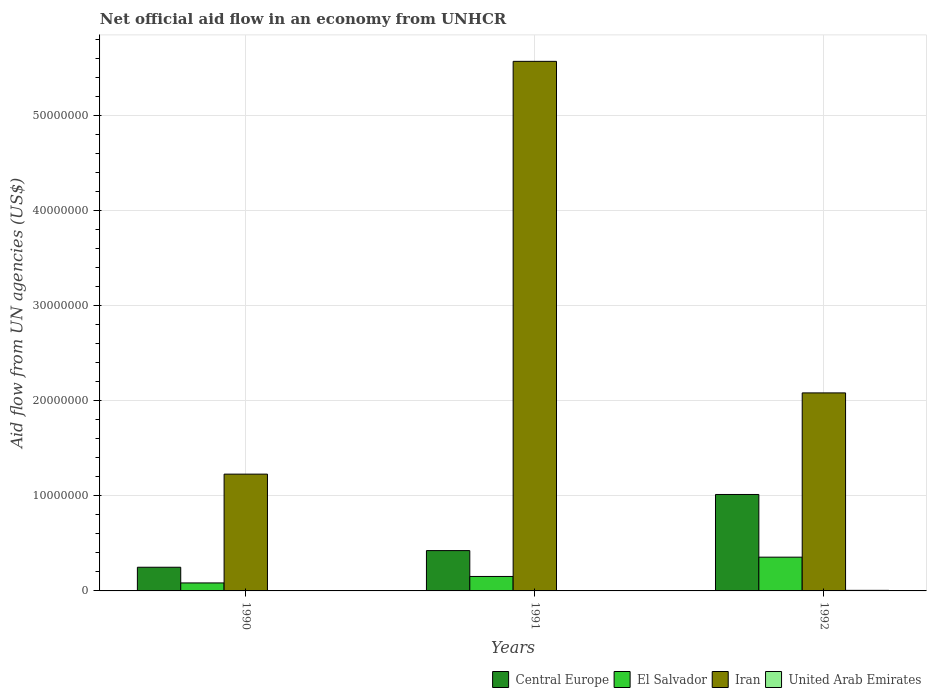How many different coloured bars are there?
Your answer should be compact. 4. How many groups of bars are there?
Make the answer very short. 3. Are the number of bars on each tick of the X-axis equal?
Ensure brevity in your answer.  Yes. How many bars are there on the 1st tick from the left?
Your answer should be very brief. 4. How many bars are there on the 2nd tick from the right?
Your answer should be very brief. 4. What is the net official aid flow in Central Europe in 1992?
Offer a very short reply. 1.01e+07. Across all years, what is the maximum net official aid flow in El Salvador?
Provide a short and direct response. 3.55e+06. Across all years, what is the minimum net official aid flow in Central Europe?
Your answer should be very brief. 2.49e+06. What is the total net official aid flow in Iran in the graph?
Ensure brevity in your answer.  8.88e+07. What is the difference between the net official aid flow in El Salvador in 1990 and that in 1991?
Offer a terse response. -6.80e+05. What is the difference between the net official aid flow in United Arab Emirates in 1992 and the net official aid flow in El Salvador in 1991?
Provide a succinct answer. -1.46e+06. What is the average net official aid flow in United Arab Emirates per year?
Your answer should be very brief. 4.00e+04. In the year 1990, what is the difference between the net official aid flow in United Arab Emirates and net official aid flow in Iran?
Ensure brevity in your answer.  -1.23e+07. In how many years, is the net official aid flow in Iran greater than 4000000 US$?
Your answer should be compact. 3. What is the ratio of the net official aid flow in United Arab Emirates in 1990 to that in 1991?
Your response must be concise. 0.5. Is the difference between the net official aid flow in United Arab Emirates in 1990 and 1992 greater than the difference between the net official aid flow in Iran in 1990 and 1992?
Ensure brevity in your answer.  Yes. What is the difference between the highest and the lowest net official aid flow in Iran?
Ensure brevity in your answer.  4.34e+07. Is the sum of the net official aid flow in Central Europe in 1990 and 1991 greater than the maximum net official aid flow in United Arab Emirates across all years?
Provide a short and direct response. Yes. What does the 1st bar from the left in 1991 represents?
Provide a short and direct response. Central Europe. What does the 2nd bar from the right in 1992 represents?
Provide a succinct answer. Iran. Is it the case that in every year, the sum of the net official aid flow in Central Europe and net official aid flow in Iran is greater than the net official aid flow in El Salvador?
Offer a terse response. Yes. How many bars are there?
Your response must be concise. 12. Are all the bars in the graph horizontal?
Provide a succinct answer. No. How many years are there in the graph?
Your answer should be very brief. 3. Does the graph contain grids?
Keep it short and to the point. Yes. How many legend labels are there?
Ensure brevity in your answer.  4. What is the title of the graph?
Make the answer very short. Net official aid flow in an economy from UNHCR. Does "Greece" appear as one of the legend labels in the graph?
Make the answer very short. No. What is the label or title of the X-axis?
Provide a short and direct response. Years. What is the label or title of the Y-axis?
Offer a very short reply. Aid flow from UN agencies (US$). What is the Aid flow from UN agencies (US$) in Central Europe in 1990?
Make the answer very short. 2.49e+06. What is the Aid flow from UN agencies (US$) in El Salvador in 1990?
Your answer should be compact. 8.40e+05. What is the Aid flow from UN agencies (US$) of Iran in 1990?
Offer a very short reply. 1.23e+07. What is the Aid flow from UN agencies (US$) of United Arab Emirates in 1990?
Offer a terse response. 2.00e+04. What is the Aid flow from UN agencies (US$) of Central Europe in 1991?
Keep it short and to the point. 4.24e+06. What is the Aid flow from UN agencies (US$) in El Salvador in 1991?
Make the answer very short. 1.52e+06. What is the Aid flow from UN agencies (US$) in Iran in 1991?
Give a very brief answer. 5.57e+07. What is the Aid flow from UN agencies (US$) in Central Europe in 1992?
Provide a succinct answer. 1.01e+07. What is the Aid flow from UN agencies (US$) of El Salvador in 1992?
Make the answer very short. 3.55e+06. What is the Aid flow from UN agencies (US$) in Iran in 1992?
Provide a short and direct response. 2.08e+07. What is the Aid flow from UN agencies (US$) of United Arab Emirates in 1992?
Your response must be concise. 6.00e+04. Across all years, what is the maximum Aid flow from UN agencies (US$) in Central Europe?
Your answer should be compact. 1.01e+07. Across all years, what is the maximum Aid flow from UN agencies (US$) of El Salvador?
Your answer should be compact. 3.55e+06. Across all years, what is the maximum Aid flow from UN agencies (US$) of Iran?
Give a very brief answer. 5.57e+07. Across all years, what is the maximum Aid flow from UN agencies (US$) of United Arab Emirates?
Make the answer very short. 6.00e+04. Across all years, what is the minimum Aid flow from UN agencies (US$) in Central Europe?
Ensure brevity in your answer.  2.49e+06. Across all years, what is the minimum Aid flow from UN agencies (US$) in El Salvador?
Offer a terse response. 8.40e+05. Across all years, what is the minimum Aid flow from UN agencies (US$) in Iran?
Give a very brief answer. 1.23e+07. What is the total Aid flow from UN agencies (US$) of Central Europe in the graph?
Keep it short and to the point. 1.69e+07. What is the total Aid flow from UN agencies (US$) in El Salvador in the graph?
Give a very brief answer. 5.91e+06. What is the total Aid flow from UN agencies (US$) in Iran in the graph?
Provide a short and direct response. 8.88e+07. What is the total Aid flow from UN agencies (US$) in United Arab Emirates in the graph?
Offer a very short reply. 1.20e+05. What is the difference between the Aid flow from UN agencies (US$) in Central Europe in 1990 and that in 1991?
Your response must be concise. -1.75e+06. What is the difference between the Aid flow from UN agencies (US$) in El Salvador in 1990 and that in 1991?
Offer a terse response. -6.80e+05. What is the difference between the Aid flow from UN agencies (US$) of Iran in 1990 and that in 1991?
Provide a short and direct response. -4.34e+07. What is the difference between the Aid flow from UN agencies (US$) in United Arab Emirates in 1990 and that in 1991?
Your answer should be compact. -2.00e+04. What is the difference between the Aid flow from UN agencies (US$) in Central Europe in 1990 and that in 1992?
Offer a very short reply. -7.65e+06. What is the difference between the Aid flow from UN agencies (US$) in El Salvador in 1990 and that in 1992?
Ensure brevity in your answer.  -2.71e+06. What is the difference between the Aid flow from UN agencies (US$) of Iran in 1990 and that in 1992?
Give a very brief answer. -8.54e+06. What is the difference between the Aid flow from UN agencies (US$) in United Arab Emirates in 1990 and that in 1992?
Your response must be concise. -4.00e+04. What is the difference between the Aid flow from UN agencies (US$) in Central Europe in 1991 and that in 1992?
Make the answer very short. -5.90e+06. What is the difference between the Aid flow from UN agencies (US$) of El Salvador in 1991 and that in 1992?
Keep it short and to the point. -2.03e+06. What is the difference between the Aid flow from UN agencies (US$) in Iran in 1991 and that in 1992?
Give a very brief answer. 3.49e+07. What is the difference between the Aid flow from UN agencies (US$) in Central Europe in 1990 and the Aid flow from UN agencies (US$) in El Salvador in 1991?
Keep it short and to the point. 9.70e+05. What is the difference between the Aid flow from UN agencies (US$) of Central Europe in 1990 and the Aid flow from UN agencies (US$) of Iran in 1991?
Make the answer very short. -5.32e+07. What is the difference between the Aid flow from UN agencies (US$) in Central Europe in 1990 and the Aid flow from UN agencies (US$) in United Arab Emirates in 1991?
Provide a short and direct response. 2.45e+06. What is the difference between the Aid flow from UN agencies (US$) in El Salvador in 1990 and the Aid flow from UN agencies (US$) in Iran in 1991?
Keep it short and to the point. -5.48e+07. What is the difference between the Aid flow from UN agencies (US$) of Iran in 1990 and the Aid flow from UN agencies (US$) of United Arab Emirates in 1991?
Offer a very short reply. 1.22e+07. What is the difference between the Aid flow from UN agencies (US$) in Central Europe in 1990 and the Aid flow from UN agencies (US$) in El Salvador in 1992?
Your answer should be very brief. -1.06e+06. What is the difference between the Aid flow from UN agencies (US$) of Central Europe in 1990 and the Aid flow from UN agencies (US$) of Iran in 1992?
Your answer should be compact. -1.83e+07. What is the difference between the Aid flow from UN agencies (US$) in Central Europe in 1990 and the Aid flow from UN agencies (US$) in United Arab Emirates in 1992?
Your answer should be very brief. 2.43e+06. What is the difference between the Aid flow from UN agencies (US$) of El Salvador in 1990 and the Aid flow from UN agencies (US$) of Iran in 1992?
Give a very brief answer. -2.00e+07. What is the difference between the Aid flow from UN agencies (US$) in El Salvador in 1990 and the Aid flow from UN agencies (US$) in United Arab Emirates in 1992?
Make the answer very short. 7.80e+05. What is the difference between the Aid flow from UN agencies (US$) in Iran in 1990 and the Aid flow from UN agencies (US$) in United Arab Emirates in 1992?
Your response must be concise. 1.22e+07. What is the difference between the Aid flow from UN agencies (US$) of Central Europe in 1991 and the Aid flow from UN agencies (US$) of El Salvador in 1992?
Make the answer very short. 6.90e+05. What is the difference between the Aid flow from UN agencies (US$) in Central Europe in 1991 and the Aid flow from UN agencies (US$) in Iran in 1992?
Provide a succinct answer. -1.66e+07. What is the difference between the Aid flow from UN agencies (US$) of Central Europe in 1991 and the Aid flow from UN agencies (US$) of United Arab Emirates in 1992?
Your answer should be very brief. 4.18e+06. What is the difference between the Aid flow from UN agencies (US$) of El Salvador in 1991 and the Aid flow from UN agencies (US$) of Iran in 1992?
Provide a short and direct response. -1.93e+07. What is the difference between the Aid flow from UN agencies (US$) of El Salvador in 1991 and the Aid flow from UN agencies (US$) of United Arab Emirates in 1992?
Provide a succinct answer. 1.46e+06. What is the difference between the Aid flow from UN agencies (US$) of Iran in 1991 and the Aid flow from UN agencies (US$) of United Arab Emirates in 1992?
Keep it short and to the point. 5.56e+07. What is the average Aid flow from UN agencies (US$) of Central Europe per year?
Your answer should be very brief. 5.62e+06. What is the average Aid flow from UN agencies (US$) of El Salvador per year?
Offer a terse response. 1.97e+06. What is the average Aid flow from UN agencies (US$) of Iran per year?
Provide a succinct answer. 2.96e+07. In the year 1990, what is the difference between the Aid flow from UN agencies (US$) of Central Europe and Aid flow from UN agencies (US$) of El Salvador?
Provide a short and direct response. 1.65e+06. In the year 1990, what is the difference between the Aid flow from UN agencies (US$) in Central Europe and Aid flow from UN agencies (US$) in Iran?
Offer a terse response. -9.79e+06. In the year 1990, what is the difference between the Aid flow from UN agencies (US$) of Central Europe and Aid flow from UN agencies (US$) of United Arab Emirates?
Offer a very short reply. 2.47e+06. In the year 1990, what is the difference between the Aid flow from UN agencies (US$) in El Salvador and Aid flow from UN agencies (US$) in Iran?
Keep it short and to the point. -1.14e+07. In the year 1990, what is the difference between the Aid flow from UN agencies (US$) in El Salvador and Aid flow from UN agencies (US$) in United Arab Emirates?
Provide a succinct answer. 8.20e+05. In the year 1990, what is the difference between the Aid flow from UN agencies (US$) of Iran and Aid flow from UN agencies (US$) of United Arab Emirates?
Your answer should be very brief. 1.23e+07. In the year 1991, what is the difference between the Aid flow from UN agencies (US$) of Central Europe and Aid flow from UN agencies (US$) of El Salvador?
Give a very brief answer. 2.72e+06. In the year 1991, what is the difference between the Aid flow from UN agencies (US$) in Central Europe and Aid flow from UN agencies (US$) in Iran?
Make the answer very short. -5.14e+07. In the year 1991, what is the difference between the Aid flow from UN agencies (US$) in Central Europe and Aid flow from UN agencies (US$) in United Arab Emirates?
Ensure brevity in your answer.  4.20e+06. In the year 1991, what is the difference between the Aid flow from UN agencies (US$) of El Salvador and Aid flow from UN agencies (US$) of Iran?
Give a very brief answer. -5.42e+07. In the year 1991, what is the difference between the Aid flow from UN agencies (US$) of El Salvador and Aid flow from UN agencies (US$) of United Arab Emirates?
Your answer should be compact. 1.48e+06. In the year 1991, what is the difference between the Aid flow from UN agencies (US$) of Iran and Aid flow from UN agencies (US$) of United Arab Emirates?
Keep it short and to the point. 5.56e+07. In the year 1992, what is the difference between the Aid flow from UN agencies (US$) of Central Europe and Aid flow from UN agencies (US$) of El Salvador?
Provide a short and direct response. 6.59e+06. In the year 1992, what is the difference between the Aid flow from UN agencies (US$) in Central Europe and Aid flow from UN agencies (US$) in Iran?
Your answer should be very brief. -1.07e+07. In the year 1992, what is the difference between the Aid flow from UN agencies (US$) in Central Europe and Aid flow from UN agencies (US$) in United Arab Emirates?
Ensure brevity in your answer.  1.01e+07. In the year 1992, what is the difference between the Aid flow from UN agencies (US$) in El Salvador and Aid flow from UN agencies (US$) in Iran?
Provide a short and direct response. -1.73e+07. In the year 1992, what is the difference between the Aid flow from UN agencies (US$) in El Salvador and Aid flow from UN agencies (US$) in United Arab Emirates?
Your answer should be very brief. 3.49e+06. In the year 1992, what is the difference between the Aid flow from UN agencies (US$) of Iran and Aid flow from UN agencies (US$) of United Arab Emirates?
Provide a short and direct response. 2.08e+07. What is the ratio of the Aid flow from UN agencies (US$) of Central Europe in 1990 to that in 1991?
Give a very brief answer. 0.59. What is the ratio of the Aid flow from UN agencies (US$) in El Salvador in 1990 to that in 1991?
Ensure brevity in your answer.  0.55. What is the ratio of the Aid flow from UN agencies (US$) in Iran in 1990 to that in 1991?
Your answer should be very brief. 0.22. What is the ratio of the Aid flow from UN agencies (US$) in United Arab Emirates in 1990 to that in 1991?
Keep it short and to the point. 0.5. What is the ratio of the Aid flow from UN agencies (US$) of Central Europe in 1990 to that in 1992?
Offer a terse response. 0.25. What is the ratio of the Aid flow from UN agencies (US$) in El Salvador in 1990 to that in 1992?
Your answer should be very brief. 0.24. What is the ratio of the Aid flow from UN agencies (US$) of Iran in 1990 to that in 1992?
Give a very brief answer. 0.59. What is the ratio of the Aid flow from UN agencies (US$) in Central Europe in 1991 to that in 1992?
Keep it short and to the point. 0.42. What is the ratio of the Aid flow from UN agencies (US$) of El Salvador in 1991 to that in 1992?
Provide a short and direct response. 0.43. What is the ratio of the Aid flow from UN agencies (US$) of Iran in 1991 to that in 1992?
Ensure brevity in your answer.  2.67. What is the ratio of the Aid flow from UN agencies (US$) in United Arab Emirates in 1991 to that in 1992?
Give a very brief answer. 0.67. What is the difference between the highest and the second highest Aid flow from UN agencies (US$) of Central Europe?
Make the answer very short. 5.90e+06. What is the difference between the highest and the second highest Aid flow from UN agencies (US$) of El Salvador?
Provide a short and direct response. 2.03e+06. What is the difference between the highest and the second highest Aid flow from UN agencies (US$) of Iran?
Your response must be concise. 3.49e+07. What is the difference between the highest and the lowest Aid flow from UN agencies (US$) of Central Europe?
Your answer should be compact. 7.65e+06. What is the difference between the highest and the lowest Aid flow from UN agencies (US$) in El Salvador?
Give a very brief answer. 2.71e+06. What is the difference between the highest and the lowest Aid flow from UN agencies (US$) of Iran?
Your answer should be very brief. 4.34e+07. What is the difference between the highest and the lowest Aid flow from UN agencies (US$) in United Arab Emirates?
Your answer should be very brief. 4.00e+04. 